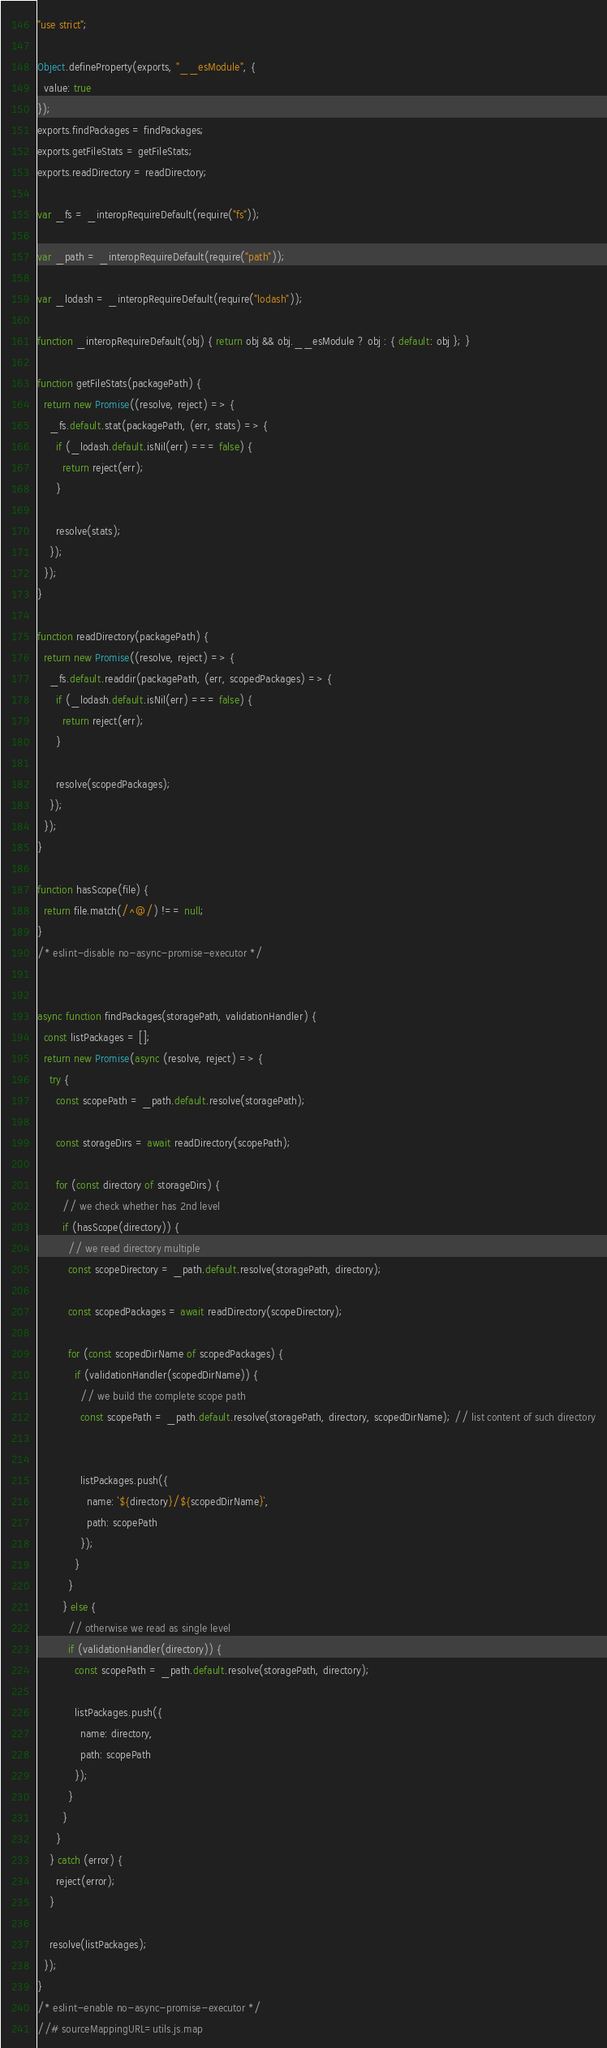Convert code to text. <code><loc_0><loc_0><loc_500><loc_500><_JavaScript_>"use strict";

Object.defineProperty(exports, "__esModule", {
  value: true
});
exports.findPackages = findPackages;
exports.getFileStats = getFileStats;
exports.readDirectory = readDirectory;

var _fs = _interopRequireDefault(require("fs"));

var _path = _interopRequireDefault(require("path"));

var _lodash = _interopRequireDefault(require("lodash"));

function _interopRequireDefault(obj) { return obj && obj.__esModule ? obj : { default: obj }; }

function getFileStats(packagePath) {
  return new Promise((resolve, reject) => {
    _fs.default.stat(packagePath, (err, stats) => {
      if (_lodash.default.isNil(err) === false) {
        return reject(err);
      }

      resolve(stats);
    });
  });
}

function readDirectory(packagePath) {
  return new Promise((resolve, reject) => {
    _fs.default.readdir(packagePath, (err, scopedPackages) => {
      if (_lodash.default.isNil(err) === false) {
        return reject(err);
      }

      resolve(scopedPackages);
    });
  });
}

function hasScope(file) {
  return file.match(/^@/) !== null;
}
/* eslint-disable no-async-promise-executor */


async function findPackages(storagePath, validationHandler) {
  const listPackages = [];
  return new Promise(async (resolve, reject) => {
    try {
      const scopePath = _path.default.resolve(storagePath);

      const storageDirs = await readDirectory(scopePath);

      for (const directory of storageDirs) {
        // we check whether has 2nd level
        if (hasScope(directory)) {
          // we read directory multiple
          const scopeDirectory = _path.default.resolve(storagePath, directory);

          const scopedPackages = await readDirectory(scopeDirectory);

          for (const scopedDirName of scopedPackages) {
            if (validationHandler(scopedDirName)) {
              // we build the complete scope path
              const scopePath = _path.default.resolve(storagePath, directory, scopedDirName); // list content of such directory


              listPackages.push({
                name: `${directory}/${scopedDirName}`,
                path: scopePath
              });
            }
          }
        } else {
          // otherwise we read as single level
          if (validationHandler(directory)) {
            const scopePath = _path.default.resolve(storagePath, directory);

            listPackages.push({
              name: directory,
              path: scopePath
            });
          }
        }
      }
    } catch (error) {
      reject(error);
    }

    resolve(listPackages);
  });
}
/* eslint-enable no-async-promise-executor */
//# sourceMappingURL=utils.js.map</code> 